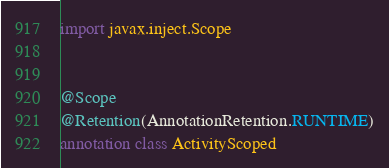Convert code to text. <code><loc_0><loc_0><loc_500><loc_500><_Kotlin_>
import javax.inject.Scope


@Scope
@Retention(AnnotationRetention.RUNTIME)
annotation class ActivityScoped
</code> 